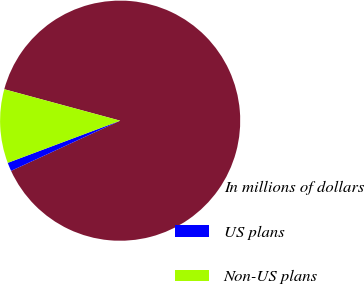Convert chart to OTSL. <chart><loc_0><loc_0><loc_500><loc_500><pie_chart><fcel>In millions of dollars<fcel>US plans<fcel>Non-US plans<nl><fcel>88.93%<fcel>1.15%<fcel>9.93%<nl></chart> 